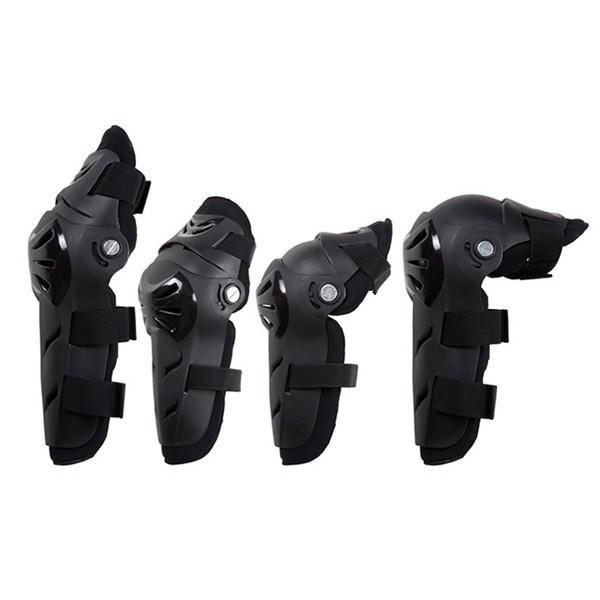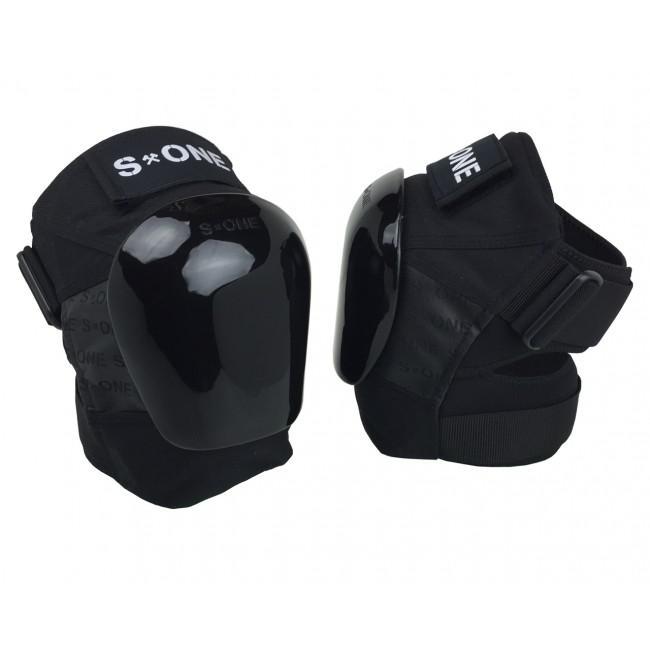The first image is the image on the left, the second image is the image on the right. For the images displayed, is the sentence "There are exactly six pads in total." factually correct? Answer yes or no. Yes. The first image is the image on the left, the second image is the image on the right. Given the left and right images, does the statement "there are 6 kneepads per image pair" hold true? Answer yes or no. Yes. 